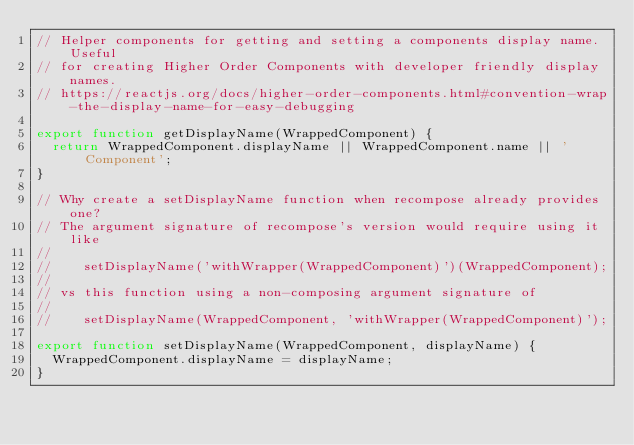<code> <loc_0><loc_0><loc_500><loc_500><_JavaScript_>// Helper components for getting and setting a components display name. Useful
// for creating Higher Order Components with developer friendly display names.
// https://reactjs.org/docs/higher-order-components.html#convention-wrap-the-display-name-for-easy-debugging

export function getDisplayName(WrappedComponent) {
  return WrappedComponent.displayName || WrappedComponent.name || 'Component';
}

// Why create a setDisplayName function when recompose already provides one?
// The argument signature of recompose's version would require using it like
//
//    setDisplayName('withWrapper(WrappedComponent)')(WrappedComponent);
//
// vs this function using a non-composing argument signature of
//
//    setDisplayName(WrappedComponent, 'withWrapper(WrappedComponent)');

export function setDisplayName(WrappedComponent, displayName) {
  WrappedComponent.displayName = displayName;
}
</code> 